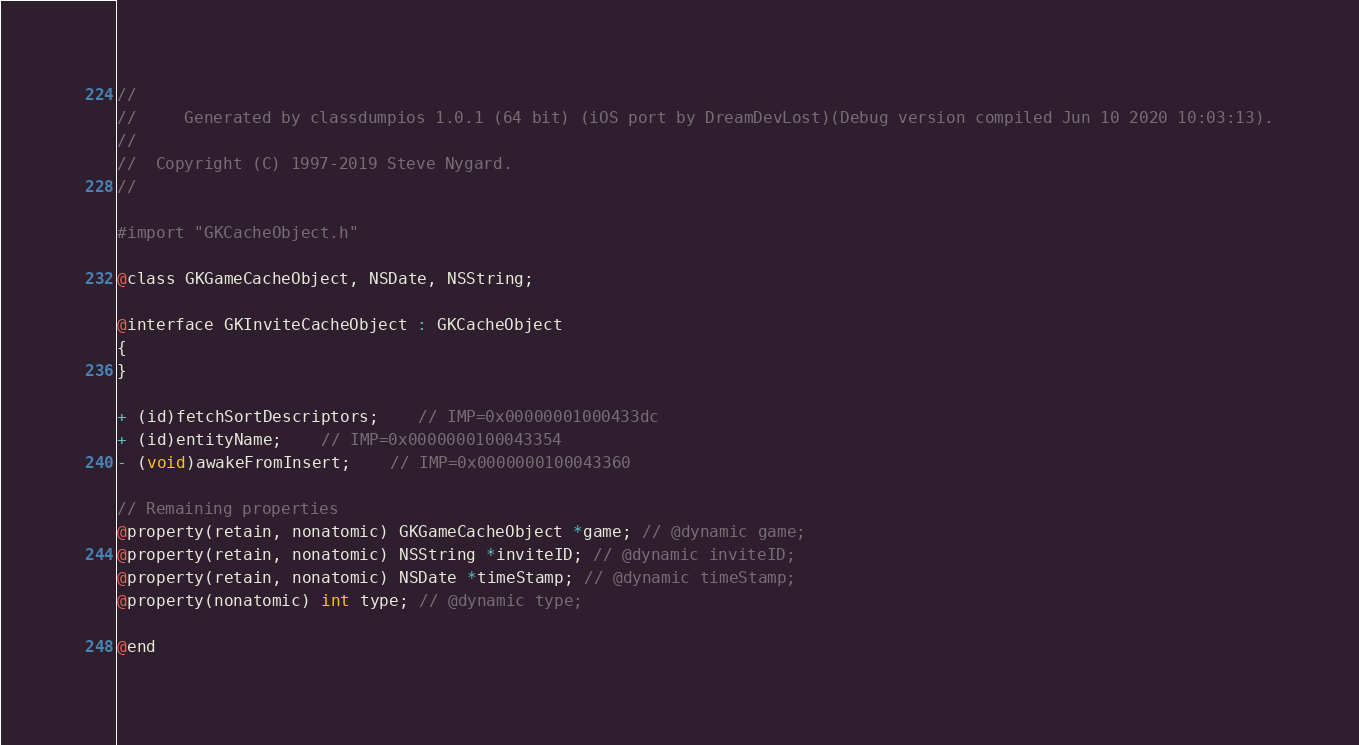Convert code to text. <code><loc_0><loc_0><loc_500><loc_500><_C_>//
//     Generated by classdumpios 1.0.1 (64 bit) (iOS port by DreamDevLost)(Debug version compiled Jun 10 2020 10:03:13).
//
//  Copyright (C) 1997-2019 Steve Nygard.
//

#import "GKCacheObject.h"

@class GKGameCacheObject, NSDate, NSString;

@interface GKInviteCacheObject : GKCacheObject
{
}

+ (id)fetchSortDescriptors;	// IMP=0x00000001000433dc
+ (id)entityName;	// IMP=0x0000000100043354
- (void)awakeFromInsert;	// IMP=0x0000000100043360

// Remaining properties
@property(retain, nonatomic) GKGameCacheObject *game; // @dynamic game;
@property(retain, nonatomic) NSString *inviteID; // @dynamic inviteID;
@property(retain, nonatomic) NSDate *timeStamp; // @dynamic timeStamp;
@property(nonatomic) int type; // @dynamic type;

@end

</code> 